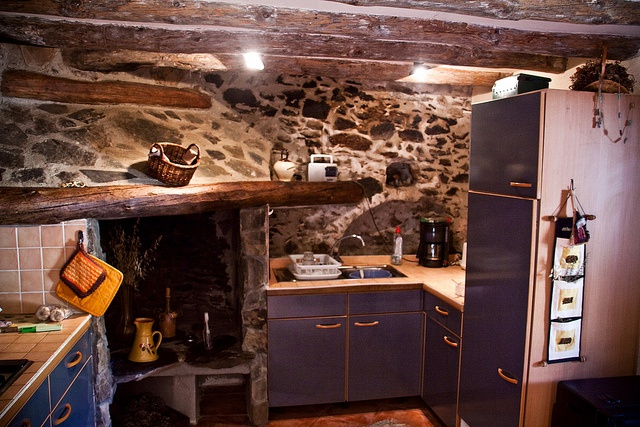Describe the objects in this image and their specific colors. I can see refrigerator in black, maroon, pink, and brown tones, oven in black, maroon, purple, and tan tones, vase in black, maroon, and brown tones, sink in black, purple, and maroon tones, and bottle in black, darkgray, gray, and maroon tones in this image. 